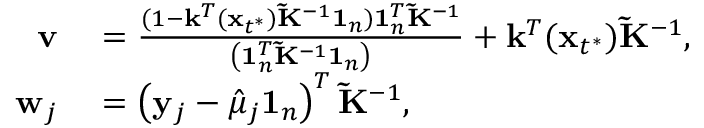<formula> <loc_0><loc_0><loc_500><loc_500>\begin{array} { r l } { v } & = \frac { ( 1 - \mathbf k ^ { T } ( \mathbf x _ { t ^ { * } } ) \tilde { K } ^ { - 1 } \mathbf 1 _ { n } ) 1 _ { n } ^ { T } { \tilde { K } } ^ { - 1 } } { \left ( 1 _ { n } ^ { T } { \tilde { K } } ^ { - 1 } 1 _ { n } \right ) } + \mathbf k ^ { T } ( \mathbf x _ { t ^ { * } } ) \tilde { K } ^ { - 1 } , } \\ { w _ { j } } & = \left ( y _ { j } - \hat { \mu } _ { j } 1 _ { n } \right ) ^ { T } \tilde { K } ^ { - 1 } , } \end{array}</formula> 